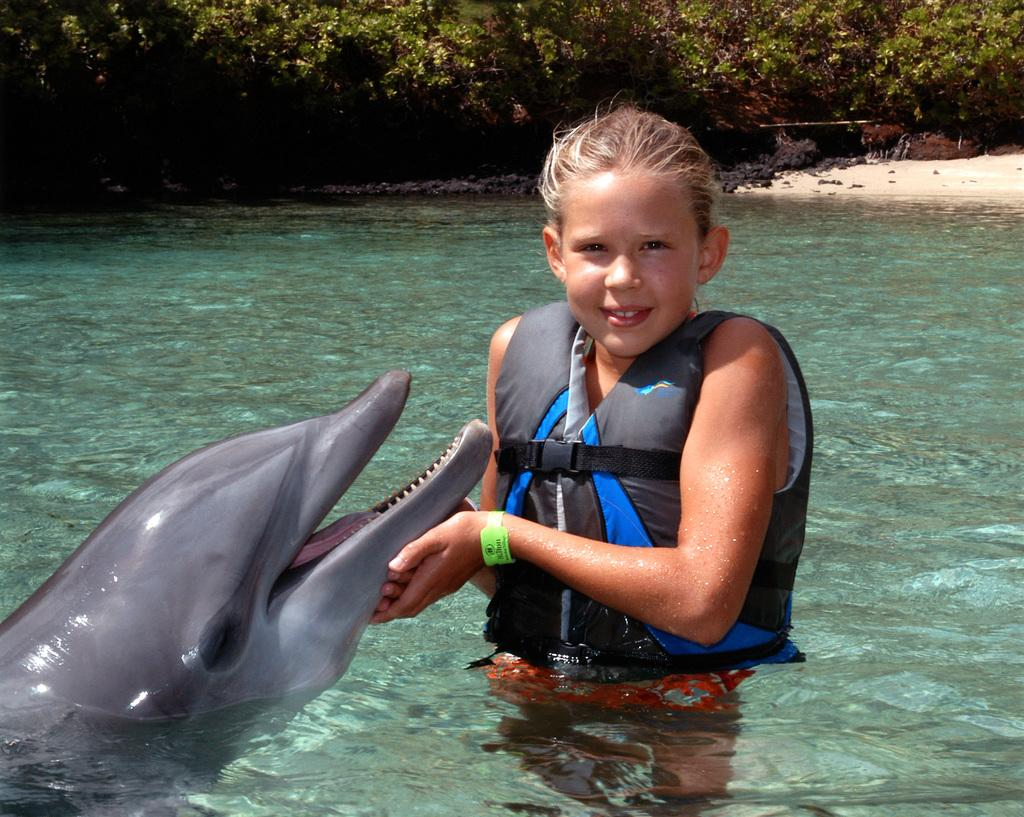Who is the main subject in the image? There is a girl in the image. What is the girl wearing? The girl is wearing a jacket. Where is the girl standing? The girl is standing in water. What is the girl holding in her hands? The girl is holding a dolphin with her hands. What type of banana can be seen kicking a ball in the image? There is no banana or ball present in the image; it features a girl holding a dolphin in water. What color is the yarn that the girl is using to knit a scarf in the image? There is no yarn or knitting activity present in the image; the girl is holding a dolphin in water. 